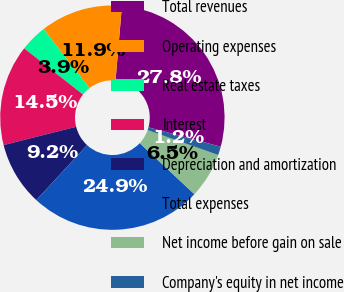Convert chart. <chart><loc_0><loc_0><loc_500><loc_500><pie_chart><fcel>Total revenues<fcel>Operating expenses<fcel>Real estate taxes<fcel>Interest<fcel>Depreciation and amortization<fcel>Total expenses<fcel>Net income before gain on sale<fcel>Company's equity in net income<nl><fcel>27.82%<fcel>11.87%<fcel>3.89%<fcel>14.53%<fcel>9.21%<fcel>24.91%<fcel>6.55%<fcel>1.23%<nl></chart> 